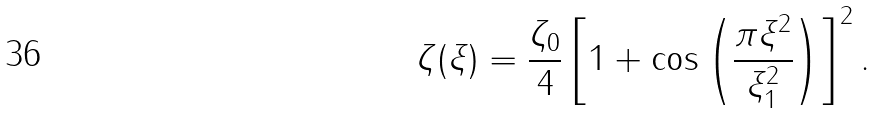Convert formula to latex. <formula><loc_0><loc_0><loc_500><loc_500>\zeta ( \xi ) = \frac { \zeta _ { 0 } } { 4 } \left [ 1 + \cos \left ( \frac { \pi \xi ^ { 2 } } { \xi _ { 1 } ^ { 2 } } \right ) \right ] ^ { 2 } .</formula> 